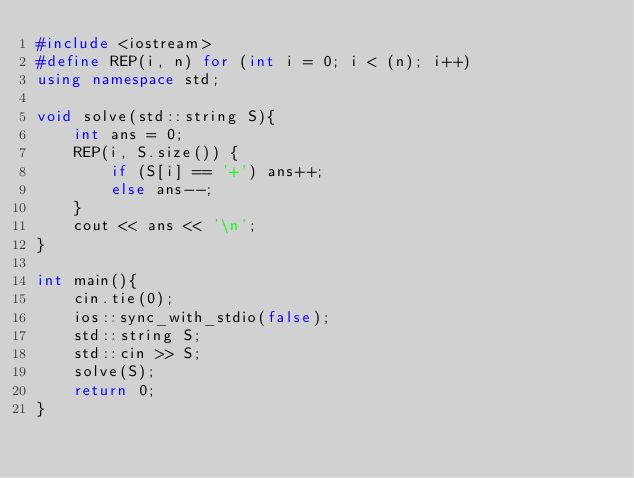Convert code to text. <code><loc_0><loc_0><loc_500><loc_500><_C++_>#include <iostream>
#define REP(i, n) for (int i = 0; i < (n); i++)
using namespace std;

void solve(std::string S){
    int ans = 0;
    REP(i, S.size()) {
        if (S[i] == '+') ans++;
        else ans--;
    }
    cout << ans << '\n';
}

int main(){
    cin.tie(0);
    ios::sync_with_stdio(false);
    std::string S;
    std::cin >> S;
    solve(S);
    return 0;
}
</code> 